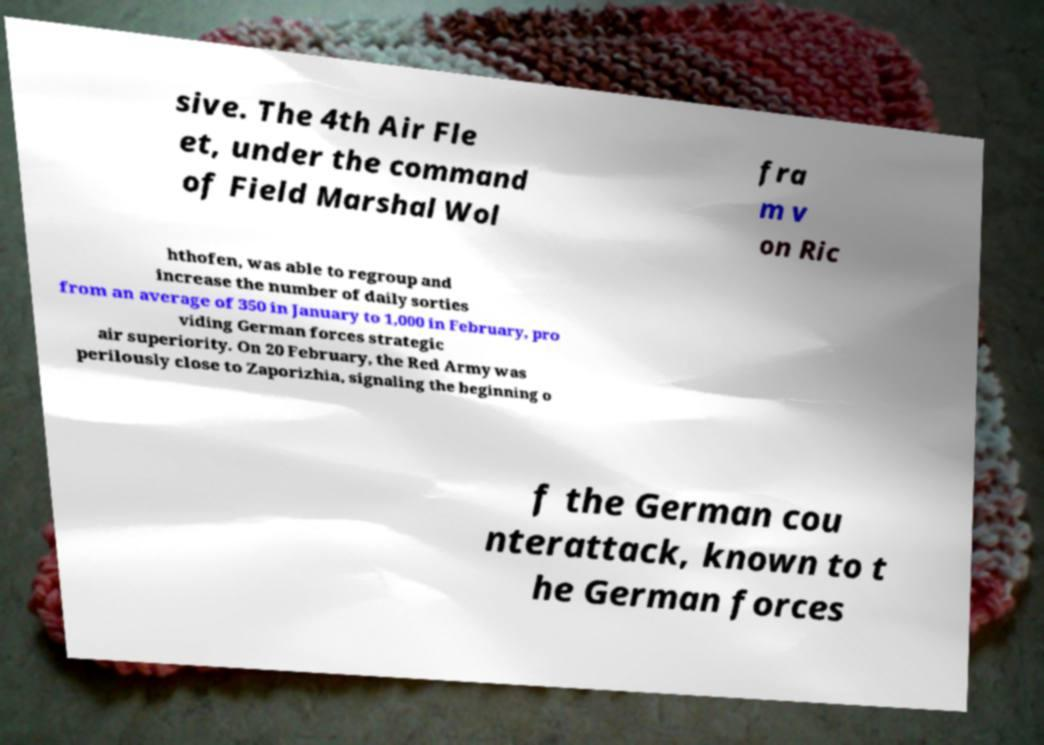Please identify and transcribe the text found in this image. sive. The 4th Air Fle et, under the command of Field Marshal Wol fra m v on Ric hthofen, was able to regroup and increase the number of daily sorties from an average of 350 in January to 1,000 in February, pro viding German forces strategic air superiority. On 20 February, the Red Army was perilously close to Zaporizhia, signaling the beginning o f the German cou nterattack, known to t he German forces 